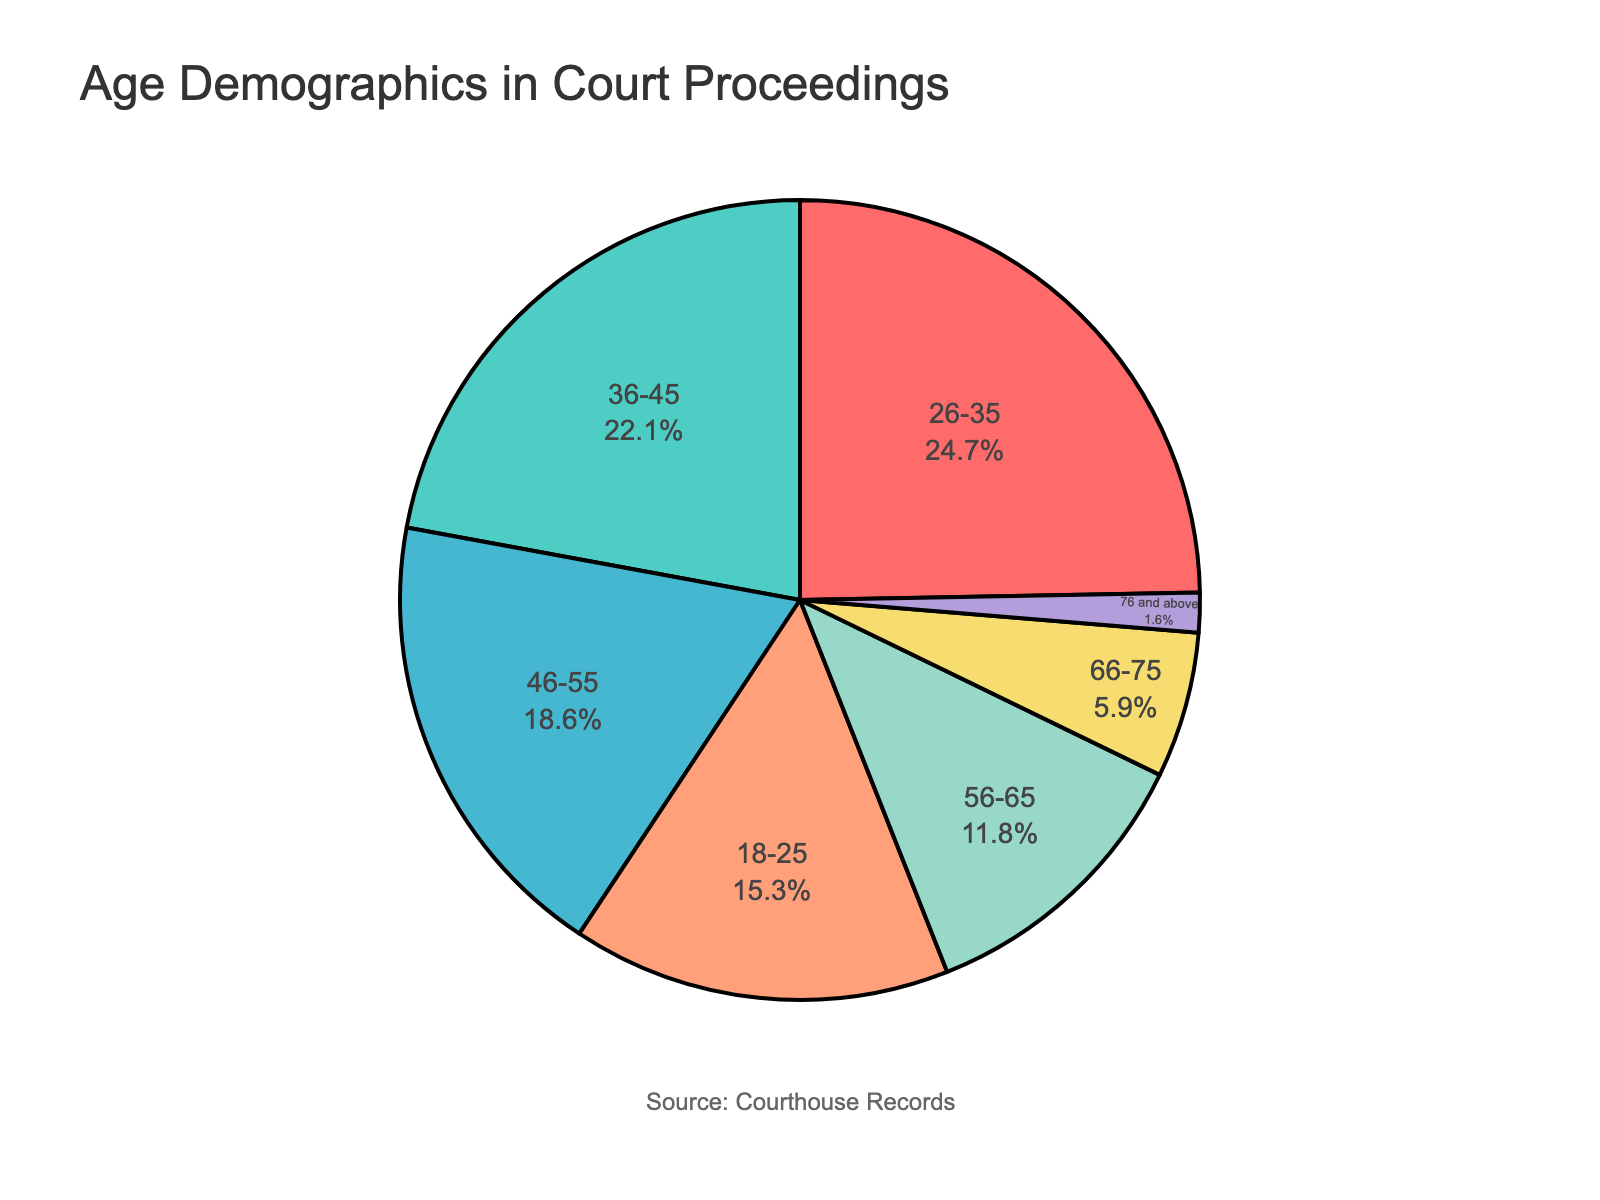What percentage of individuals appearing in court are aged between 26-35? Look at the pie chart segment labeled "26-35" and check the associated percentage.
Answer: 24.7% What is the total percentage of individuals appearing in court who are aged between 46-65? Add the percentages of the age ranges 46-55 and 56-65. (18.6% + 11.8%)
Answer: 30.4% Which age group has the lowest representation in court proceedings? Find the pie chart segment with the smallest percentage label.
Answer: 76 and above Compare the percentage of individuals aged 36-45 with those aged 66-75. Which group is higher, and by how much? Identify the percentages for both groups and calculate the difference. (22.1% - 5.9%)
Answer: 36-45 by 16.2% If we combine the age ranges 18-25 and 26-35, what is the total percentage representation? Add the percentages of the age ranges 18-25 and 26-35. (15.3% + 24.7%)
Answer: 40.0% What proportion of individuals aged 56-65 versus those aged 18-25 appear in court? Divide the percentage of the 56-65 age group by the percentage of the 18-25 age group. (11.8% / 15.3%)
Answer: 0.77 How does the representation of individuals aged 46-55 compare to the total representation of those aged 18-35? Add the percentages of the age ranges 18-25 and 26-35, then compare the sum to the percentage of the age range 46-55. (15.3% + 24.7% = 40%) vs 18.6%
Answer: Less; 18-35 has 40%, while 46-55 has 18.6% Can you find the age range with the highest representation and state their percentage? Locate the largest segment on the pie chart and note its label and associated percentage.
Answer: 26-35 with 24.7% How much more represented are individuals aged 36-45 compared to those aged 76 and above? Subtract the percentage of the 76 and above group from the 36-45 group. (22.1% - 1.6%)
Answer: 20.5% Which age range's percentage is closest to the average of all listed age ranges? Calculate the average of all age ranges’ percentages, then find the age range with the percentage closest to this average. The average is (15.3+24.7+22.1+18.6+11.8+5.9+1.6)/7 = 14.29%.
Answer: 18-25 with 15.3% 